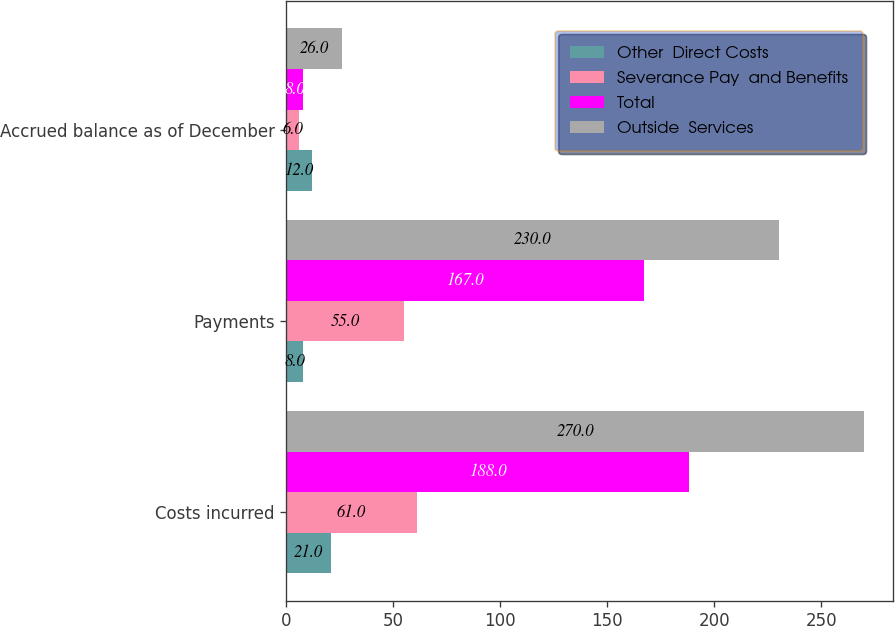<chart> <loc_0><loc_0><loc_500><loc_500><stacked_bar_chart><ecel><fcel>Costs incurred<fcel>Payments<fcel>Accrued balance as of December<nl><fcel>Other  Direct Costs<fcel>21<fcel>8<fcel>12<nl><fcel>Severance Pay  and Benefits<fcel>61<fcel>55<fcel>6<nl><fcel>Total<fcel>188<fcel>167<fcel>8<nl><fcel>Outside  Services<fcel>270<fcel>230<fcel>26<nl></chart> 